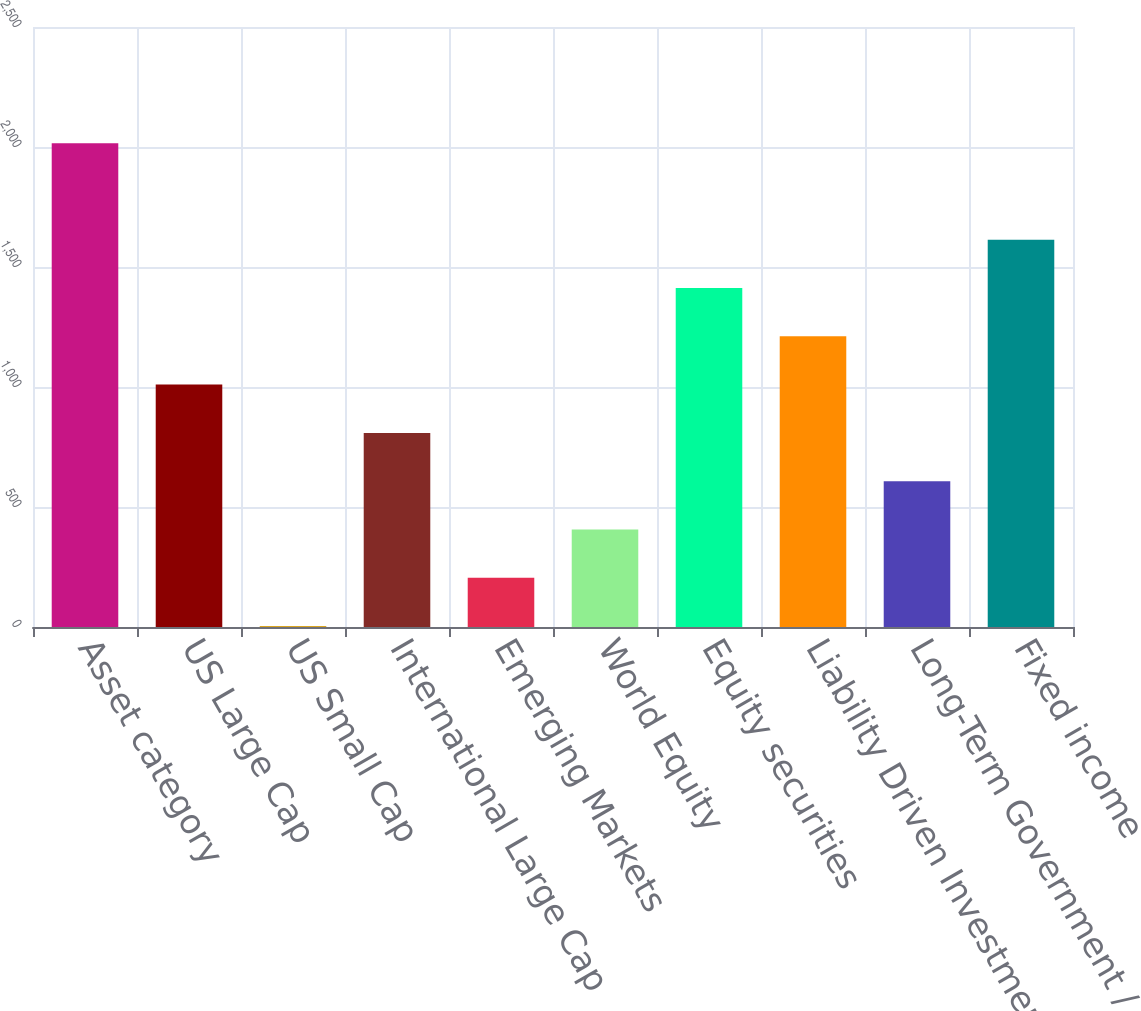Convert chart. <chart><loc_0><loc_0><loc_500><loc_500><bar_chart><fcel>Asset category<fcel>US Large Cap<fcel>US Small Cap<fcel>International Large Cap<fcel>Emerging Markets<fcel>World Equity<fcel>Equity securities<fcel>Liability Driven Investment<fcel>Long-Term Government / Credit<fcel>Fixed income<nl><fcel>2016<fcel>1010<fcel>4<fcel>808.8<fcel>205.2<fcel>406.4<fcel>1412.4<fcel>1211.2<fcel>607.6<fcel>1613.6<nl></chart> 